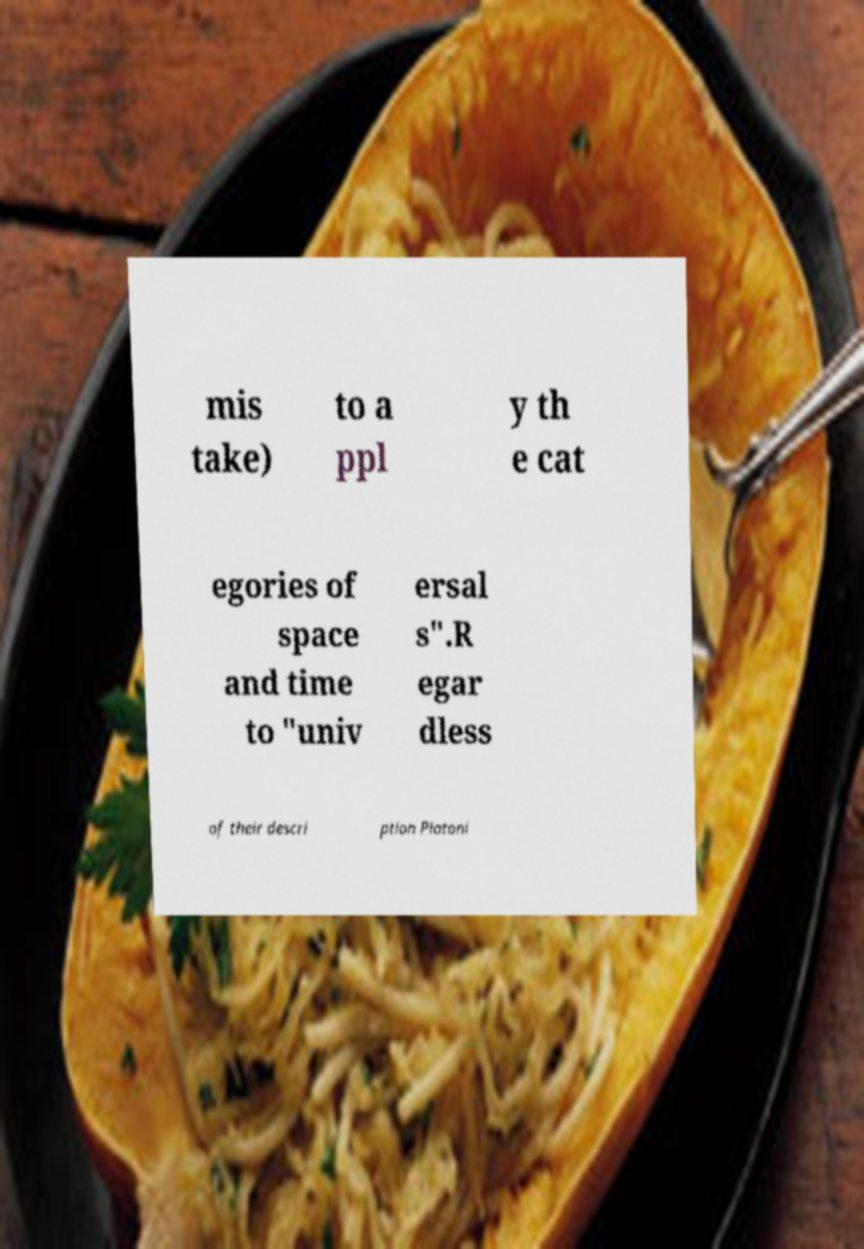Could you extract and type out the text from this image? mis take) to a ppl y th e cat egories of space and time to "univ ersal s".R egar dless of their descri ption Platoni 